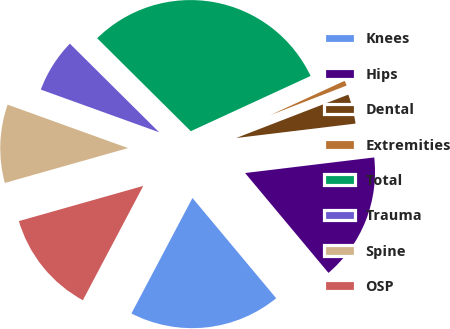Convert chart. <chart><loc_0><loc_0><loc_500><loc_500><pie_chart><fcel>Knees<fcel>Hips<fcel>Dental<fcel>Extremities<fcel>Total<fcel>Trauma<fcel>Spine<fcel>OSP<nl><fcel>18.81%<fcel>15.84%<fcel>3.96%<fcel>1.0%<fcel>30.68%<fcel>6.93%<fcel>9.9%<fcel>12.87%<nl></chart> 